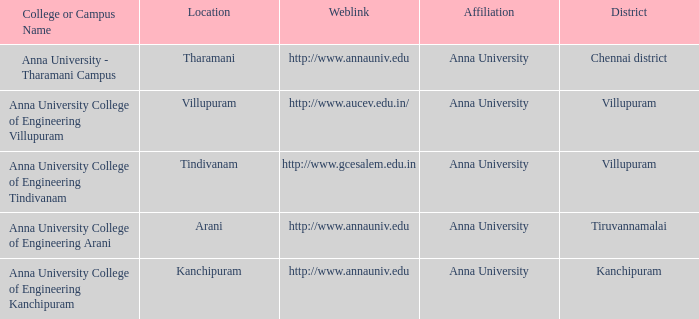What District has a Location of villupuram? Villupuram. 